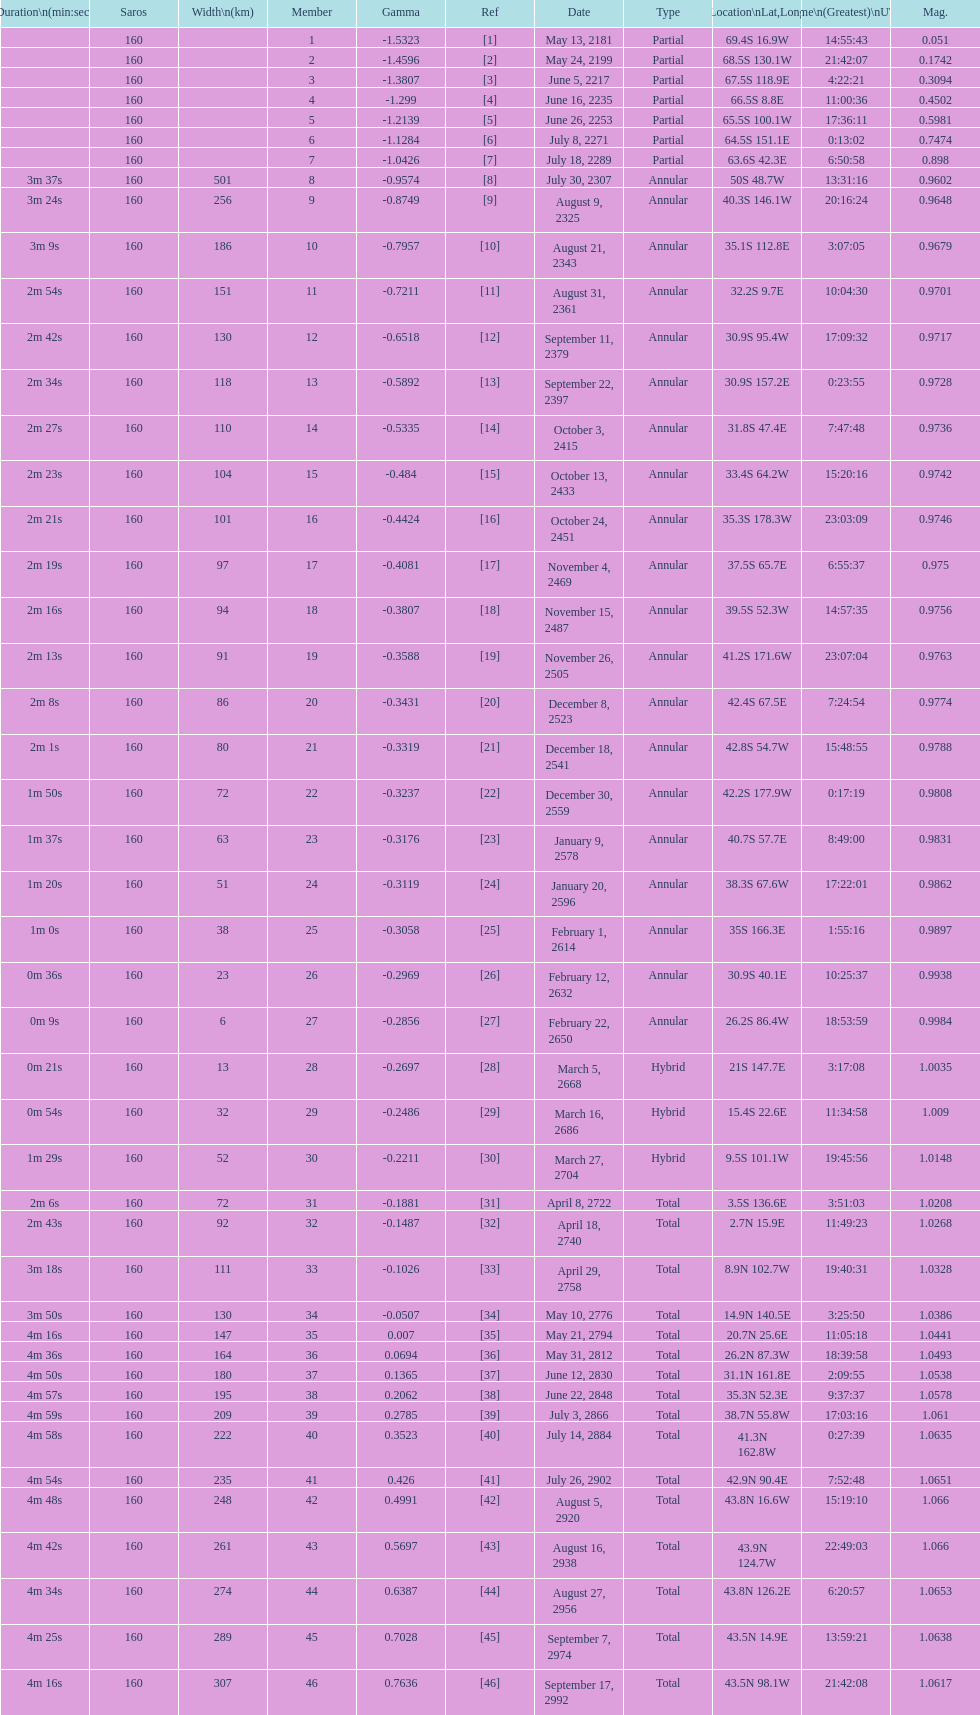Name one that has the same latitude as member number 12. 13. 